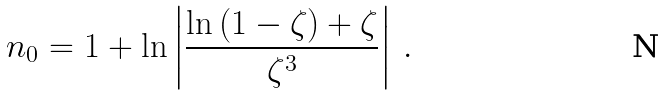Convert formula to latex. <formula><loc_0><loc_0><loc_500><loc_500>n _ { 0 } = 1 + \ln \left | \frac { \ln \left ( 1 - \zeta \right ) + \zeta } { \zeta ^ { 3 } } \right | \, .</formula> 